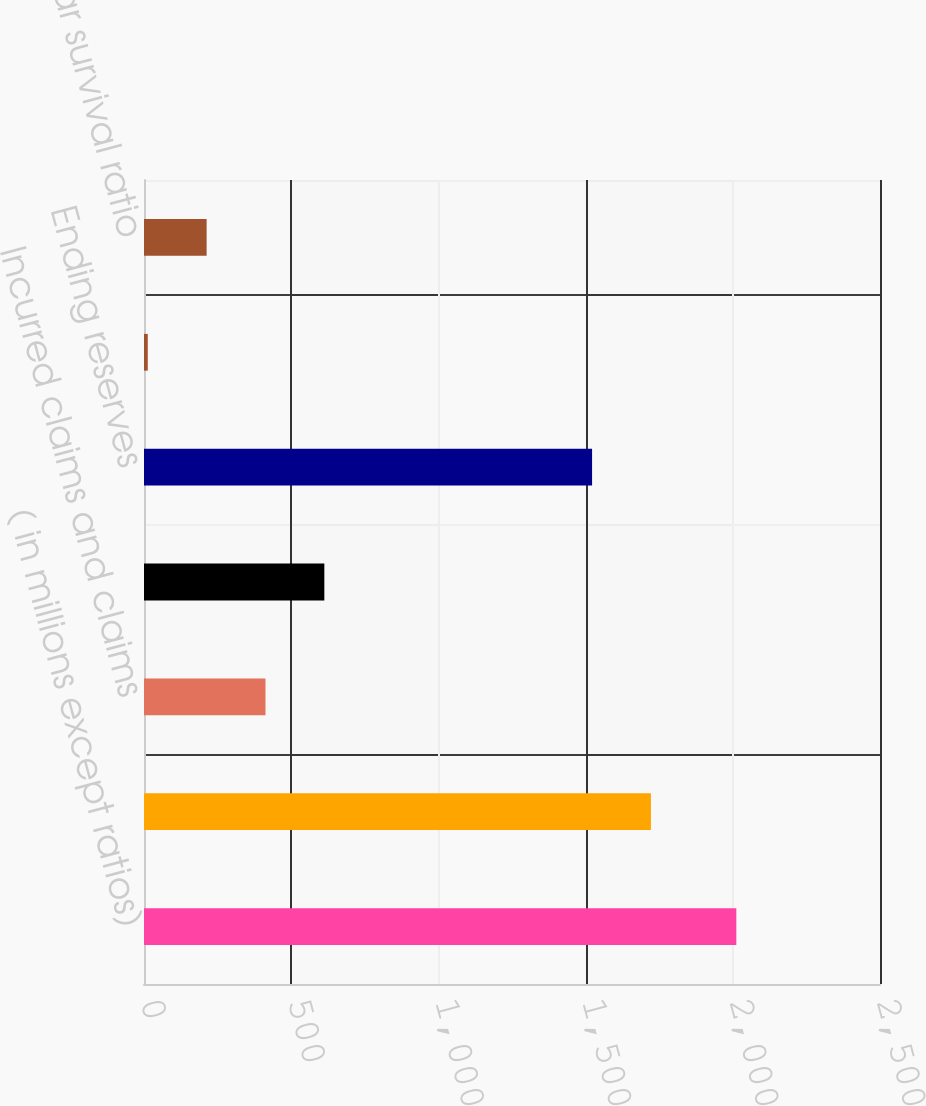Convert chart to OTSL. <chart><loc_0><loc_0><loc_500><loc_500><bar_chart><fcel>( in millions except ratios)<fcel>Beginning reserves<fcel>Incurred claims and claims<fcel>Claims and claims expense paid<fcel>Ending reserves<fcel>Annual survival ratio<fcel>3-year survival ratio<nl><fcel>2012<fcel>1721.92<fcel>412.64<fcel>612.56<fcel>1522<fcel>12.8<fcel>212.72<nl></chart> 